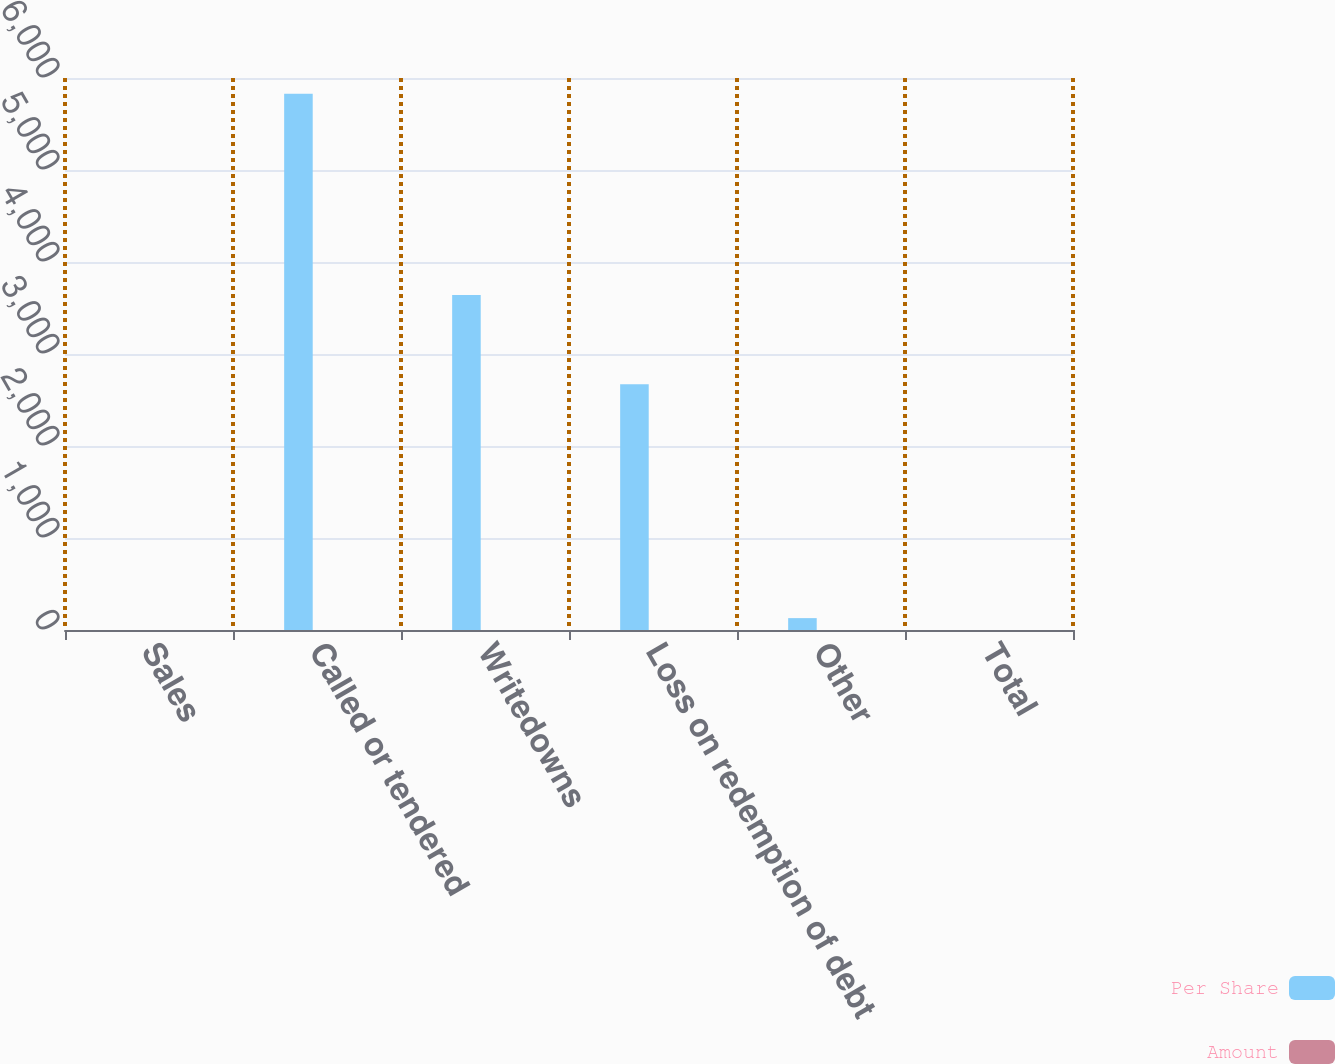<chart> <loc_0><loc_0><loc_500><loc_500><stacked_bar_chart><ecel><fcel>Sales<fcel>Called or tendered<fcel>Writedowns<fcel>Loss on redemption of debt<fcel>Other<fcel>Total<nl><fcel>Per Share<fcel>0.255<fcel>5830<fcel>3640<fcel>2671<fcel>129<fcel>0.255<nl><fcel>Amount<fcel>0.26<fcel>0.06<fcel>0.04<fcel>0.03<fcel>0<fcel>0.25<nl></chart> 